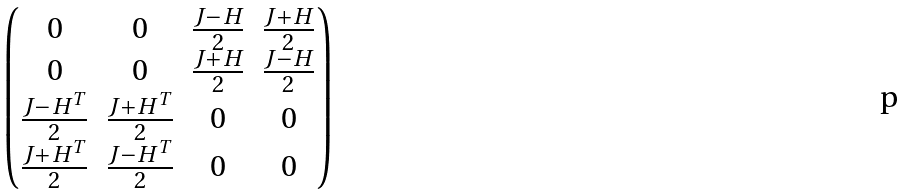<formula> <loc_0><loc_0><loc_500><loc_500>\begin{pmatrix} 0 & 0 & \frac { J - H } { 2 } & \frac { J + H } { 2 } \\ 0 & 0 & \frac { J + H } { 2 } & \frac { J - H } { 2 } \\ \frac { J - H ^ { T } } { 2 } & \frac { J + H ^ { T } } { 2 } & 0 & 0 \\ \frac { J + H ^ { T } } { 2 } & \frac { J - H ^ { T } } { 2 } & 0 & 0 \end{pmatrix}</formula> 